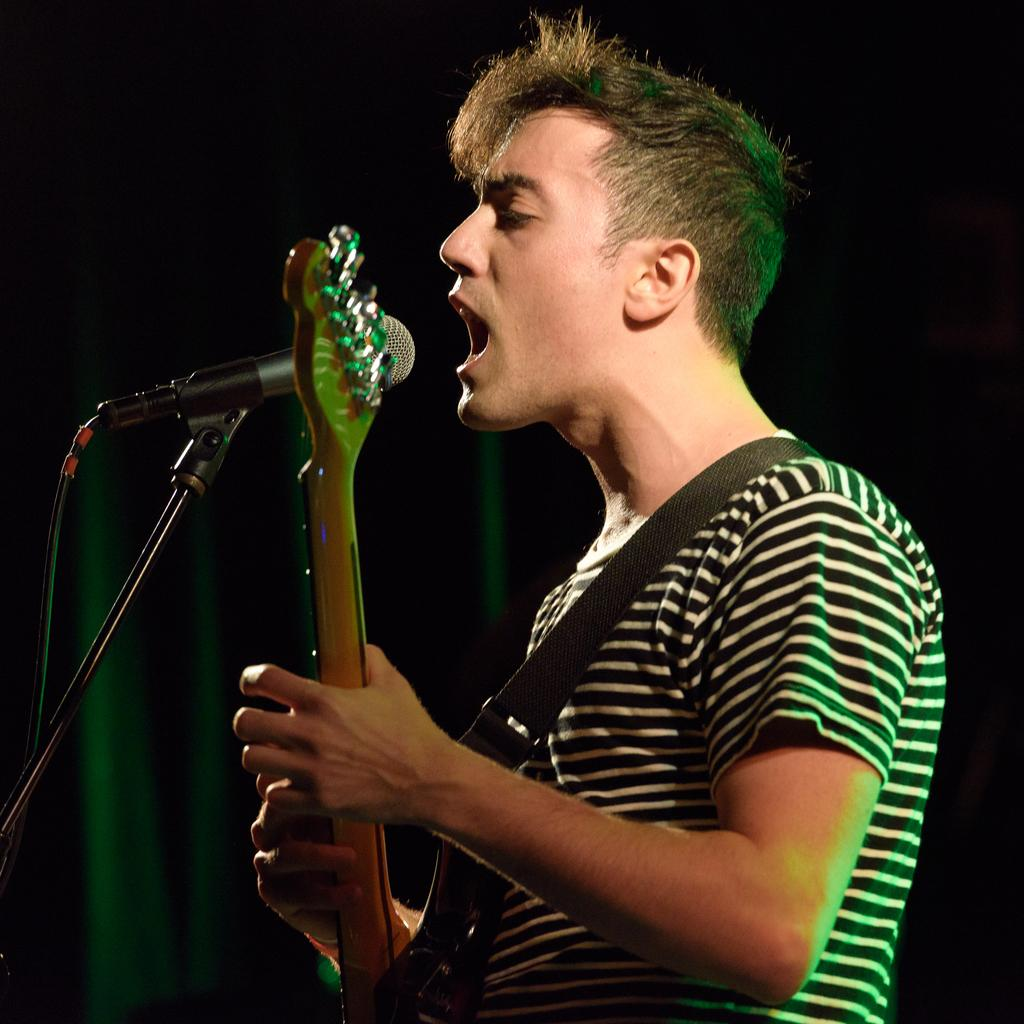What is the main subject of the image? The main subject of the image is a man. What is the man doing in the image? The man is standing and singing in the image. What object is present in the image that is commonly used for amplifying sound? There is a microphone in the image. What is the man holding in the image? The man is holding a musical instrument. What type of cloth is draped over the country in the image? There is no cloth or country present in the image; it features a man singing with a microphone and a musical instrument. 